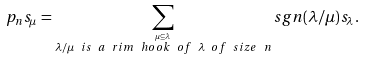<formula> <loc_0><loc_0><loc_500><loc_500>p _ { n } s _ { \mu } = \sum _ { \overset { \mu \subseteq \lambda } { \lambda / \mu \ i s \ a \ r i m \ h o o k \ o f \ \lambda \ o f \ s i z e \ n } } s g n ( \lambda / \mu ) s _ { \lambda } .</formula> 